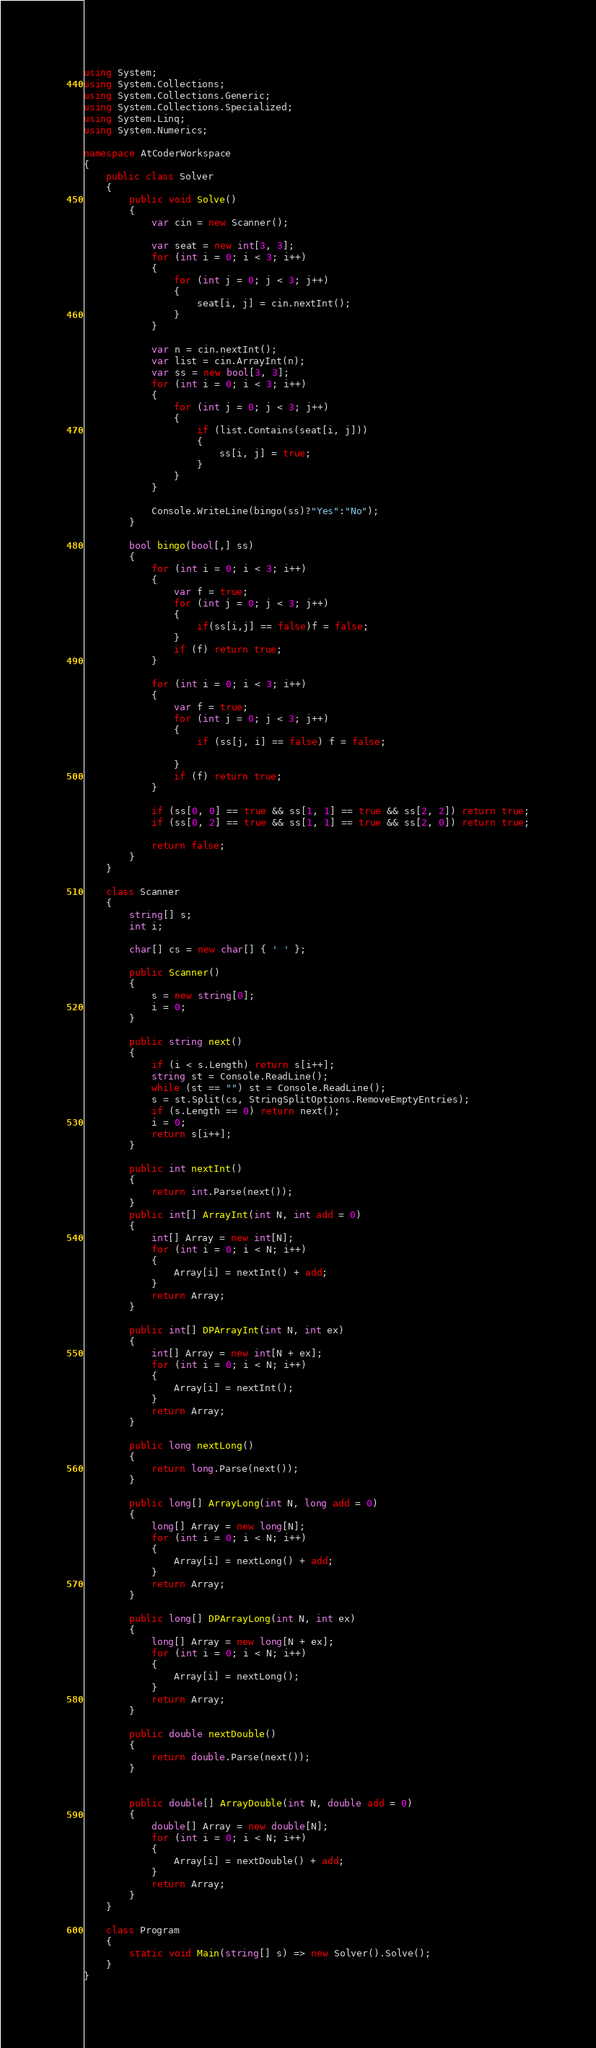<code> <loc_0><loc_0><loc_500><loc_500><_C#_>using System;
using System.Collections;
using System.Collections.Generic;
using System.Collections.Specialized;
using System.Linq;
using System.Numerics;

namespace AtCoderWorkspace
{
    public class Solver
    {
        public void Solve()
        {
            var cin = new Scanner();

            var seat = new int[3, 3];
            for (int i = 0; i < 3; i++)
            {
                for (int j = 0; j < 3; j++)
                {
                    seat[i, j] = cin.nextInt();
                }
            }

            var n = cin.nextInt();
            var list = cin.ArrayInt(n);
            var ss = new bool[3, 3];
            for (int i = 0; i < 3; i++)
            {
                for (int j = 0; j < 3; j++)
                {
                    if (list.Contains(seat[i, j]))
                    {
                        ss[i, j] = true;
                    }
                }
            }

            Console.WriteLine(bingo(ss)?"Yes":"No");
        }

        bool bingo(bool[,] ss)
        {
            for (int i = 0; i < 3; i++)
            {
                var f = true;
                for (int j = 0; j < 3; j++)
                {
                    if(ss[i,j] == false)f = false;                    
                }
                if (f) return true;
            }

            for (int i = 0; i < 3; i++)
            {
                var f = true;
                for (int j = 0; j < 3; j++)
                {
                    if (ss[j, i] == false) f = false;
                    
                }
                if (f) return true;
            }

            if (ss[0, 0] == true && ss[1, 1] == true && ss[2, 2]) return true;
            if (ss[0, 2] == true && ss[1, 1] == true && ss[2, 0]) return true;

            return false;
        }
    }

    class Scanner
    {
        string[] s;
        int i;

        char[] cs = new char[] { ' ' };

        public Scanner()
        {
            s = new string[0];
            i = 0;
        }

        public string next()
        {
            if (i < s.Length) return s[i++];
            string st = Console.ReadLine();
            while (st == "") st = Console.ReadLine();
            s = st.Split(cs, StringSplitOptions.RemoveEmptyEntries);
            if (s.Length == 0) return next();
            i = 0;
            return s[i++];
        }

        public int nextInt()
        {
            return int.Parse(next());
        }
        public int[] ArrayInt(int N, int add = 0)
        {
            int[] Array = new int[N];
            for (int i = 0; i < N; i++)
            {
                Array[i] = nextInt() + add;
            }
            return Array;
        }

        public int[] DPArrayInt(int N, int ex)
        {
            int[] Array = new int[N + ex];
            for (int i = 0; i < N; i++)
            {
                Array[i] = nextInt();
            }
            return Array;
        }

        public long nextLong()
        {
            return long.Parse(next());
        }

        public long[] ArrayLong(int N, long add = 0)
        {
            long[] Array = new long[N];
            for (int i = 0; i < N; i++)
            {
                Array[i] = nextLong() + add;
            }
            return Array;
        }

        public long[] DPArrayLong(int N, int ex)
        {
            long[] Array = new long[N + ex];
            for (int i = 0; i < N; i++)
            {
                Array[i] = nextLong();
            }
            return Array;
        }

        public double nextDouble()
        {
            return double.Parse(next());
        }


        public double[] ArrayDouble(int N, double add = 0)
        {
            double[] Array = new double[N];
            for (int i = 0; i < N; i++)
            {
                Array[i] = nextDouble() + add;
            }
            return Array;
        }
    }

    class Program
    {
        static void Main(string[] s) => new Solver().Solve();
    }
}
</code> 